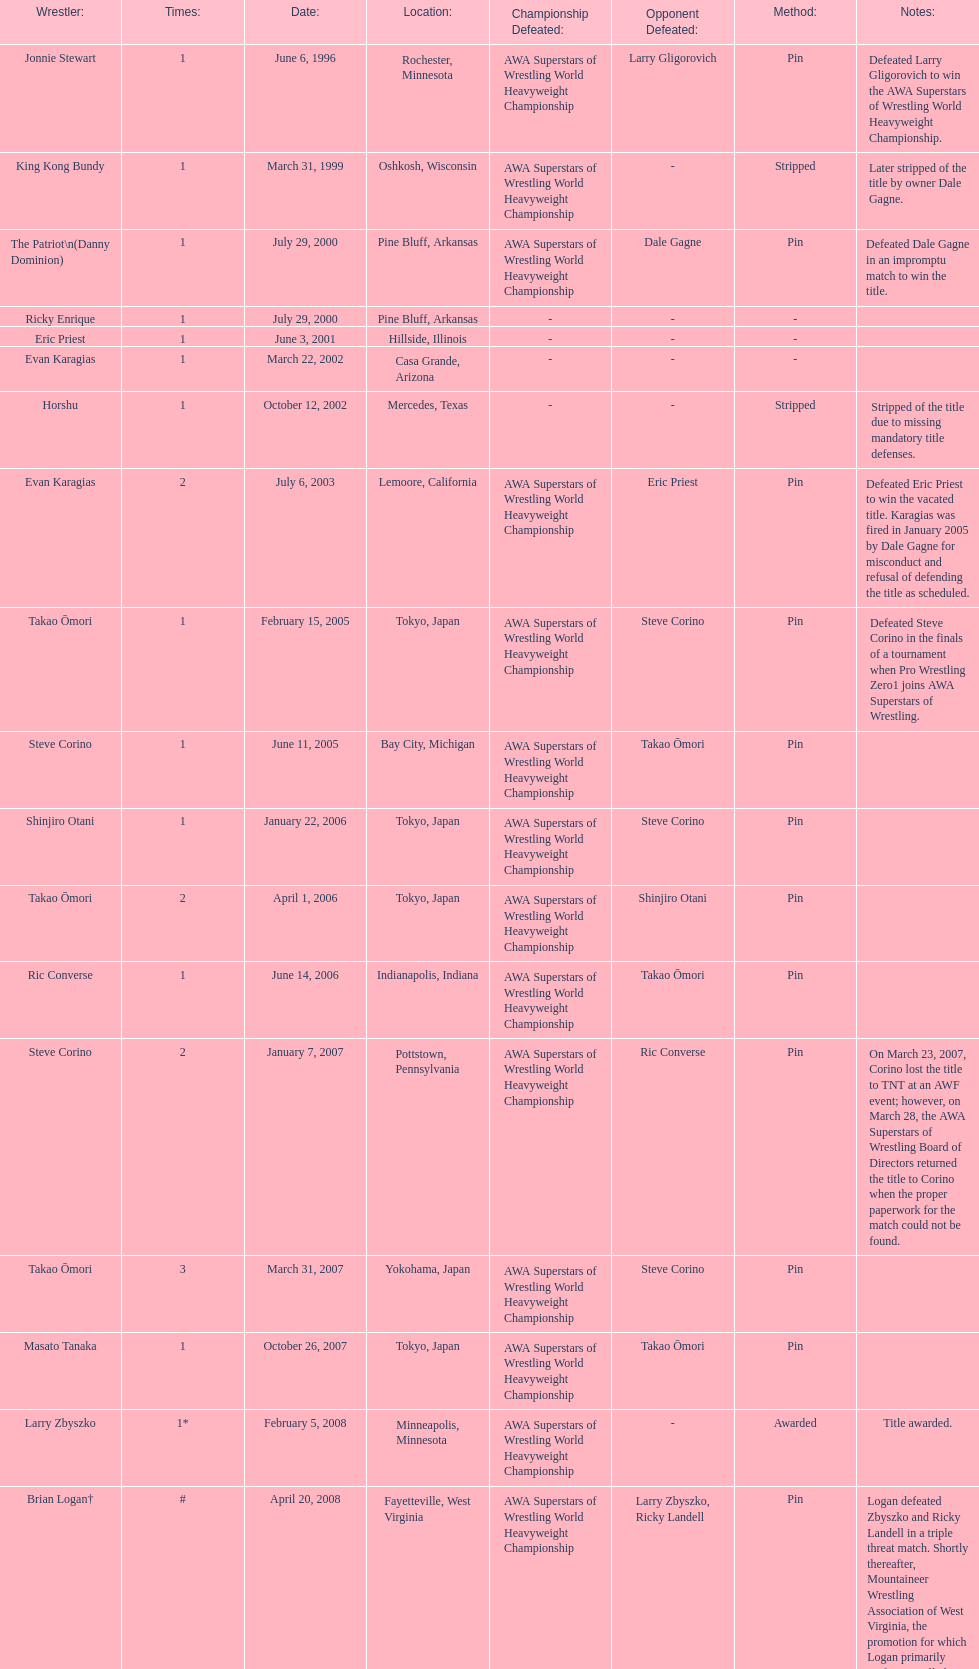Who is listed before keith walker? Ricky Landell. 